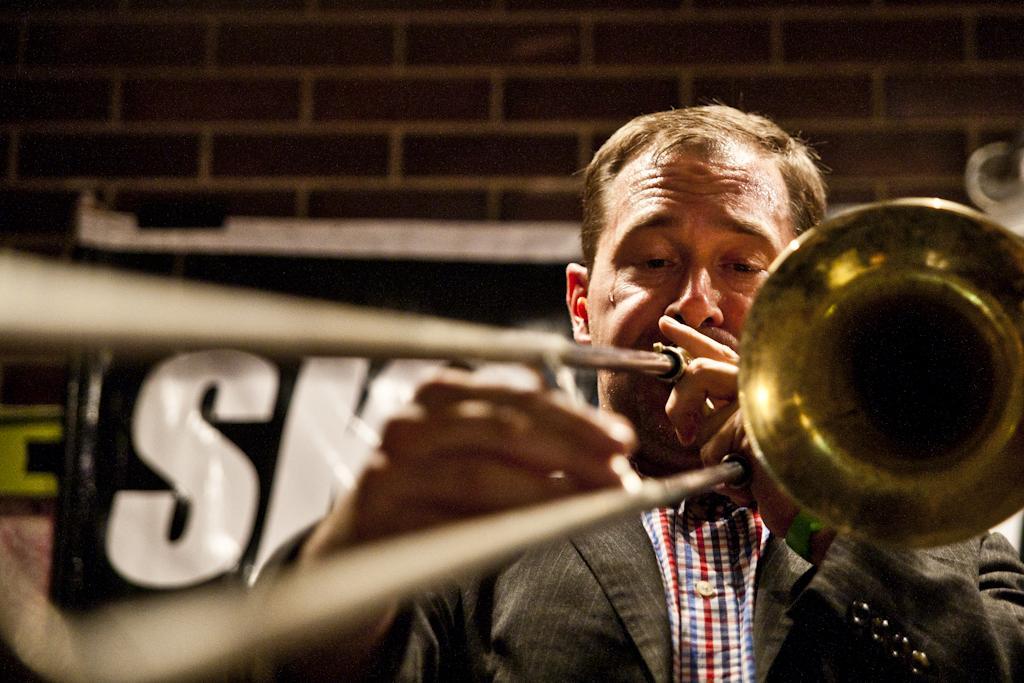Please provide a concise description of this image. In this image there is one man who is holding a musical instrument and playing. In the background there is a wall and some posters, on the poster there is text. 